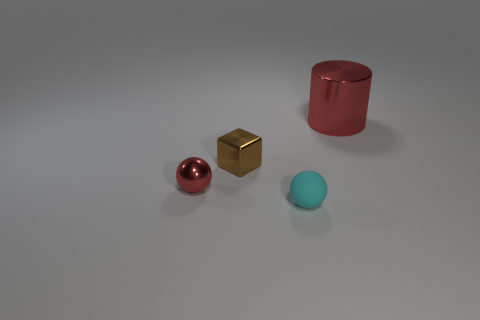What number of large things are either brown matte spheres or rubber objects?
Provide a short and direct response. 0. What is the shape of the tiny cyan matte object?
Your answer should be compact. Sphere. The other shiny object that is the same color as the big thing is what size?
Keep it short and to the point. Small. Are there any cyan spheres made of the same material as the big red cylinder?
Make the answer very short. No. Is the number of tiny green shiny cylinders greater than the number of small brown metal blocks?
Provide a succinct answer. No. Are the cyan object and the cylinder made of the same material?
Provide a short and direct response. No. What number of matte things are either small cubes or small purple things?
Give a very brief answer. 0. The shiny block that is the same size as the red metallic ball is what color?
Make the answer very short. Brown. What number of other big objects are the same shape as the cyan object?
Make the answer very short. 0. What number of cubes are either red matte objects or tiny metal objects?
Ensure brevity in your answer.  1. 